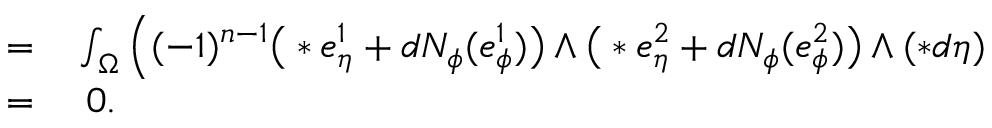<formula> <loc_0><loc_0><loc_500><loc_500>\begin{array} { r l } { = } & \int _ { \Omega } \Big ( ( - 1 ) ^ { n - 1 } \Big ( \ast e _ { \eta } ^ { 1 } + d N _ { \phi } ( e _ { \phi } ^ { 1 } ) \Big ) \wedge \Big ( \ast e _ { \eta } ^ { 2 } + d N _ { \phi } ( e _ { \phi } ^ { 2 } ) \Big ) \wedge ( \ast d \eta ) } \\ { = } & \ 0 . } \end{array}</formula> 